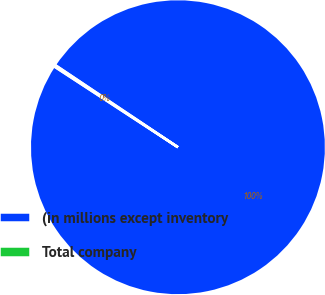Convert chart. <chart><loc_0><loc_0><loc_500><loc_500><pie_chart><fcel>(in millions except inventory<fcel>Total company<nl><fcel>99.82%<fcel>0.18%<nl></chart> 